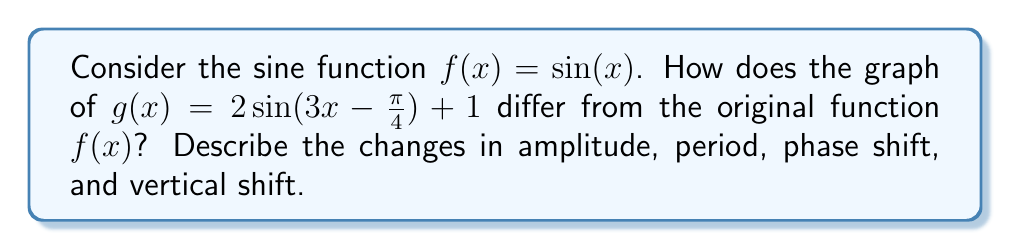Solve this math problem. Let's examine each transformation step-by-step:

1. Amplitude:
   The coefficient 2 in front of sine changes the amplitude.
   $$ \text{Amplitude} = |2| = 2 $$
   This doubles the height of the function from 1 to 2.

2. Period:
   The coefficient 3 inside the sine function affects the period.
   $$ \text{Period} = \frac{2\pi}{|3|} = \frac{2\pi}{3} $$
   This compresses the function horizontally, making the period shorter.

3. Phase shift:
   The term $-\frac{\pi}{4}$ inside the sine function causes a phase shift.
   $$ \text{Phase shift} = \frac{\pi}{4} \text{ units to the right} $$
   This is because we solve $3x - \frac{\pi}{4} = 0$ to find $x = \frac{\pi}{12}$.

4. Vertical shift:
   The +1 at the end of the function shifts the entire graph up by 1 unit.

To summarize the transformations:
- The amplitude is doubled (from 1 to 2)
- The period is reduced from $2\pi$ to $\frac{2\pi}{3}$
- The function is shifted $\frac{\pi}{12}$ units to the right
- The entire graph is shifted 1 unit up

These transformations change the shape, size, and position of the sine wave while maintaining its periodic nature.
Answer: The graph of $g(x) = 2\sin(3x - \frac{\pi}{4}) + 1$ differs from $f(x) = \sin(x)$ in the following ways:
- Amplitude increased to 2
- Period decreased to $\frac{2\pi}{3}$
- Phase shifted $\frac{\pi}{12}$ units right
- Vertically shifted 1 unit up 